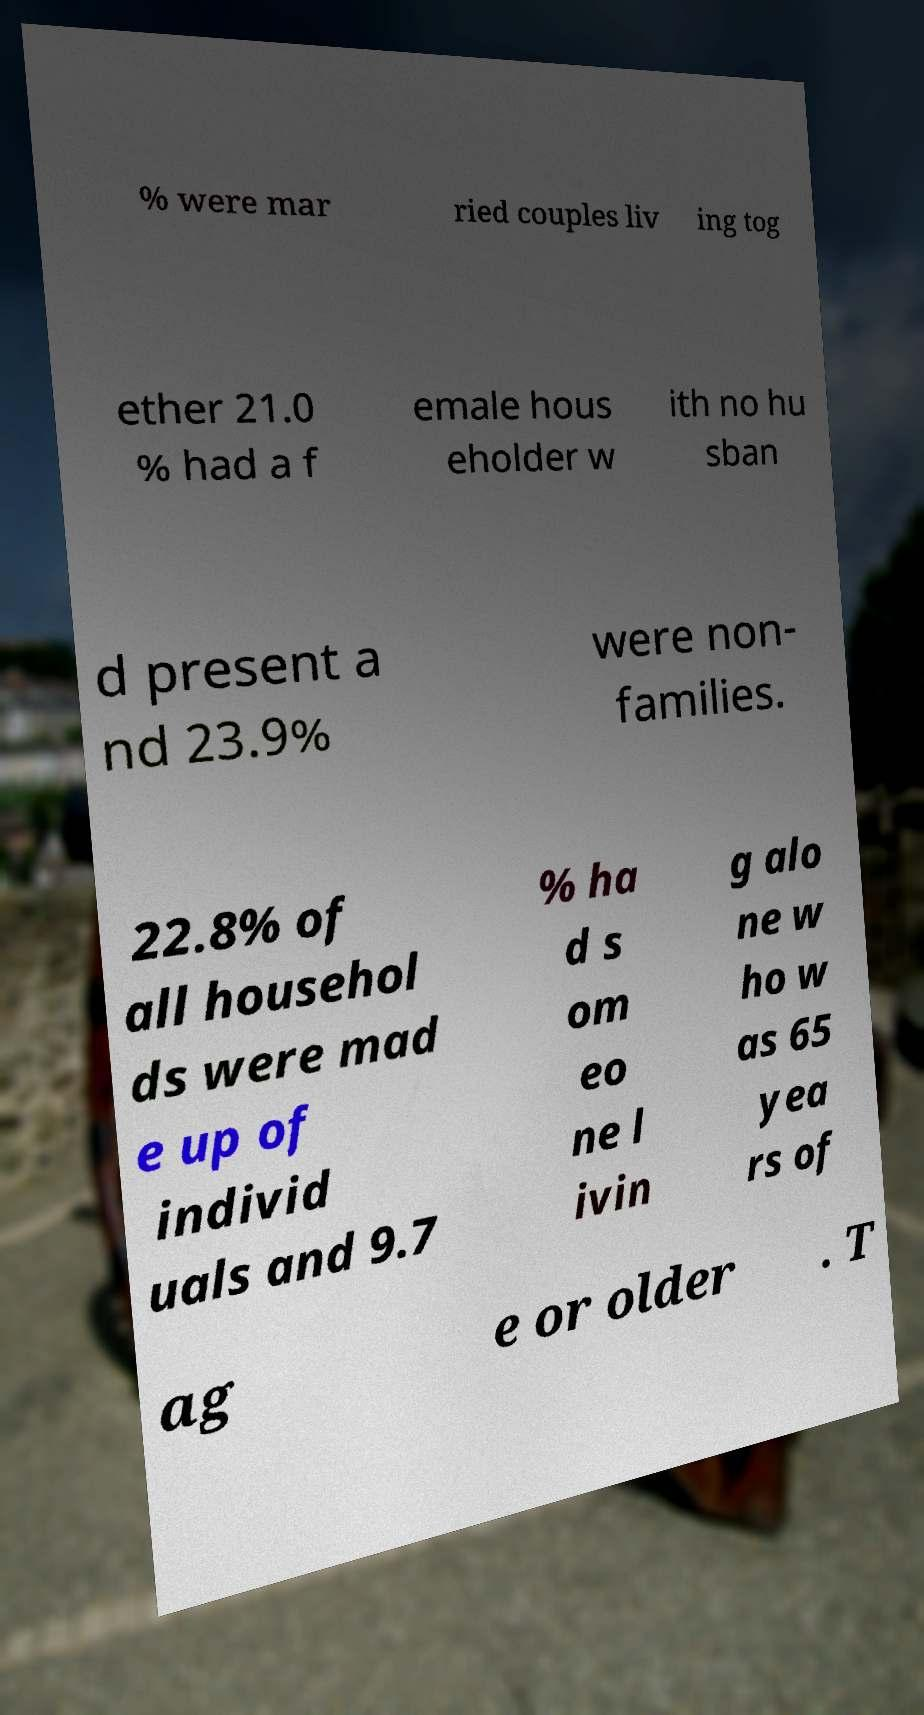Please identify and transcribe the text found in this image. % were mar ried couples liv ing tog ether 21.0 % had a f emale hous eholder w ith no hu sban d present a nd 23.9% were non- families. 22.8% of all househol ds were mad e up of individ uals and 9.7 % ha d s om eo ne l ivin g alo ne w ho w as 65 yea rs of ag e or older . T 